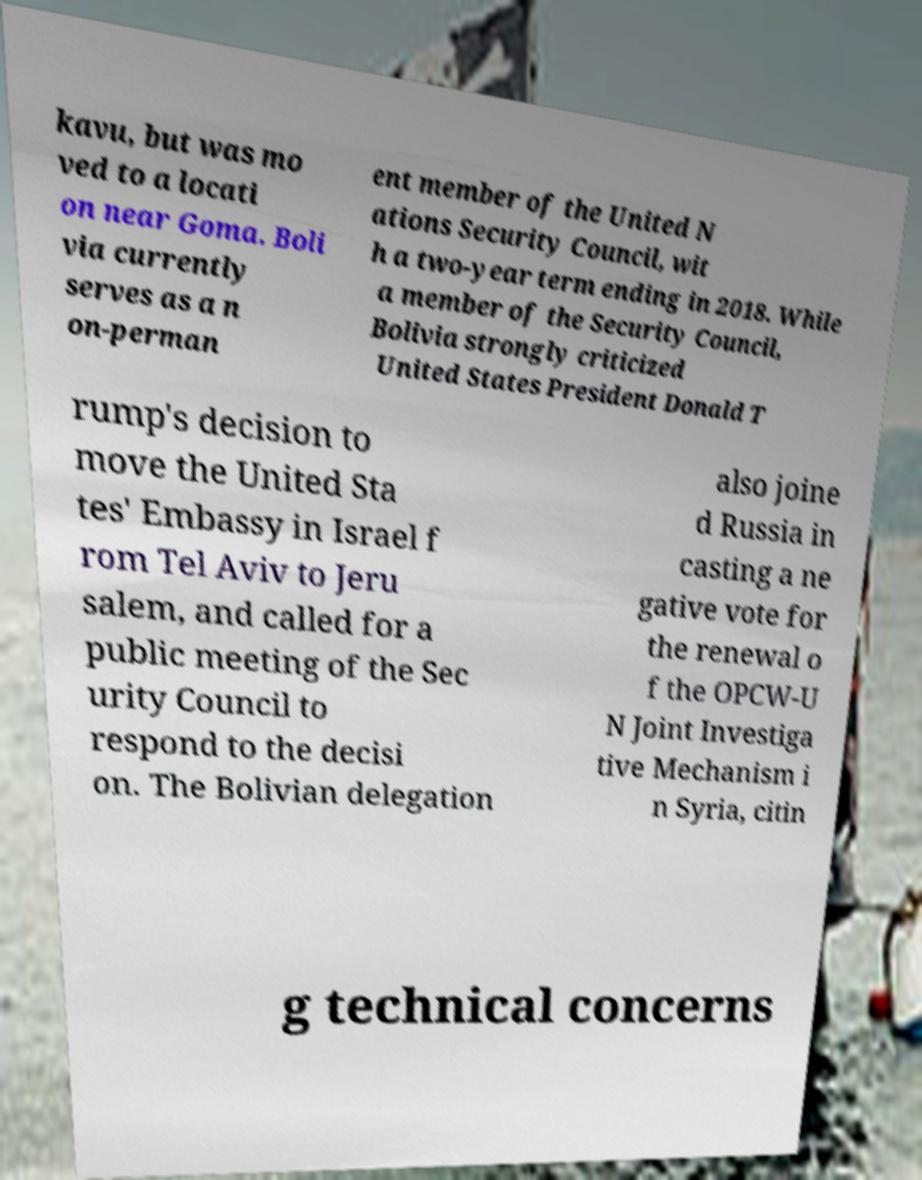I need the written content from this picture converted into text. Can you do that? kavu, but was mo ved to a locati on near Goma. Boli via currently serves as a n on-perman ent member of the United N ations Security Council, wit h a two-year term ending in 2018. While a member of the Security Council, Bolivia strongly criticized United States President Donald T rump's decision to move the United Sta tes' Embassy in Israel f rom Tel Aviv to Jeru salem, and called for a public meeting of the Sec urity Council to respond to the decisi on. The Bolivian delegation also joine d Russia in casting a ne gative vote for the renewal o f the OPCW-U N Joint Investiga tive Mechanism i n Syria, citin g technical concerns 